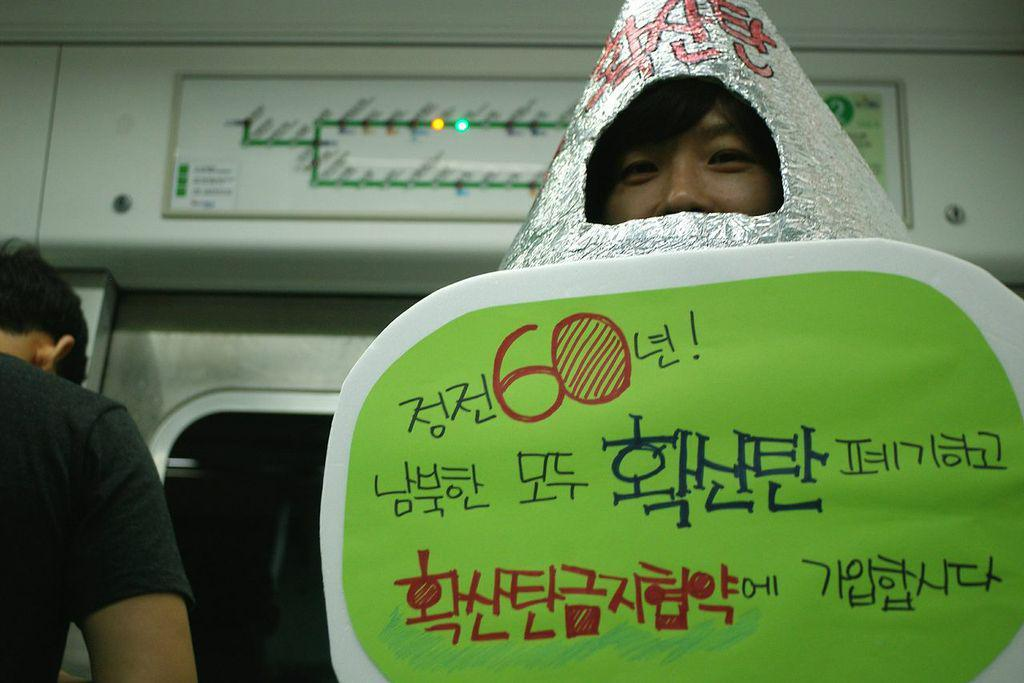How many people are in the image? There are two people in the image. What is distinctive about one of the person's attire? One person is wearing a costume. What can be seen in the background of the image? There are lights and objects visible in the background of the image. What type of plantation is visible in the image? There is no plantation present in the image. How far can the person wearing the costume stretch in the image? The image does not show the person wearing the costume stretching, so it cannot be determined from the image. 